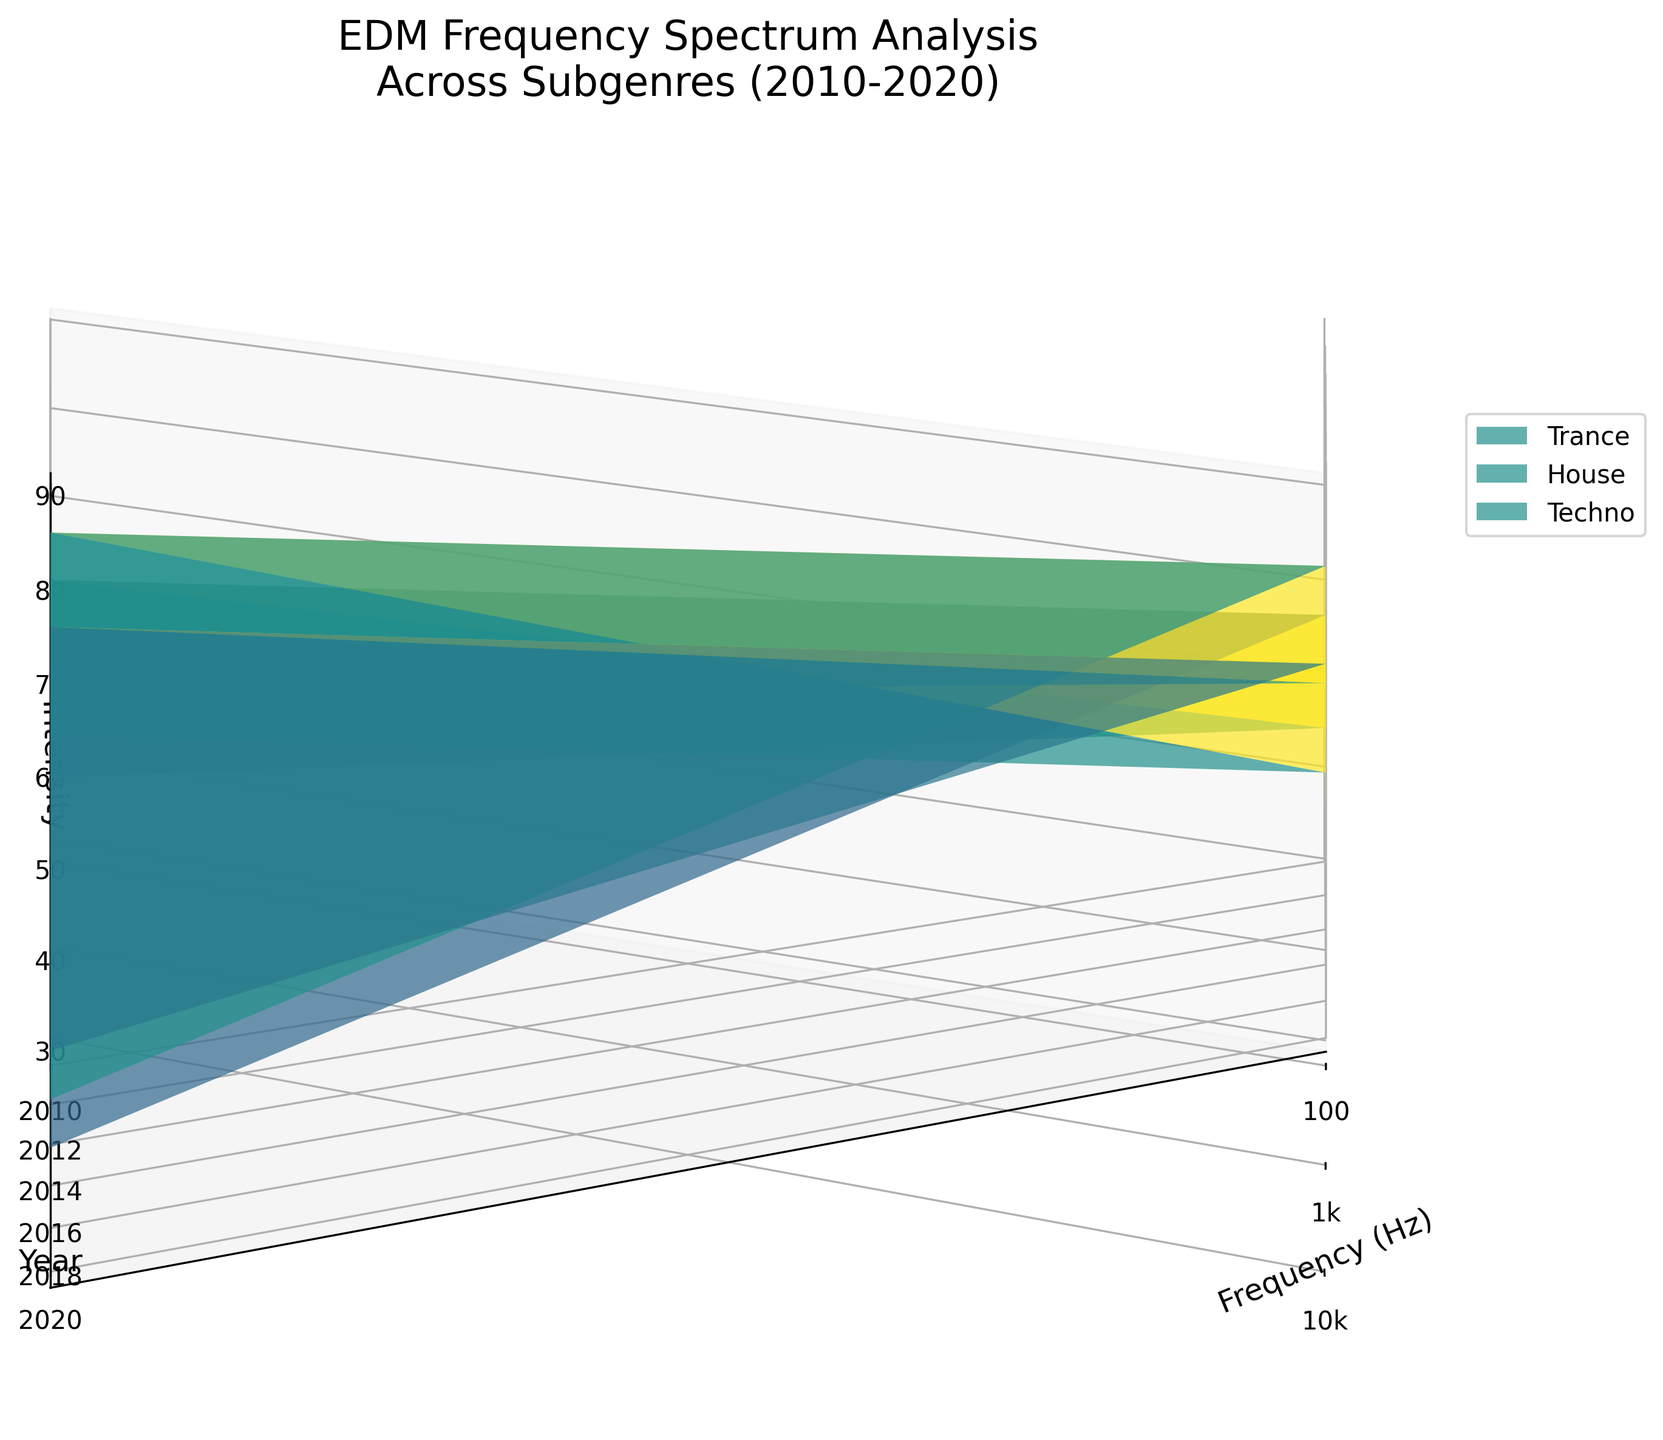What's the title of the figure? The title is prominently displayed at the top of the figure. It reads "EDM Frequency Spectrum Analysis Across Subgenres (2010-2020)."
Answer: EDM Frequency Spectrum Analysis Across Subgenres (2010-2020) What are the axes labeled as? The labels for the axes are as follows: the x-axis is labeled "Frequency (Hz)," the y-axis is labeled "Year," and the z-axis is labeled "Intensity."
Answer: Frequency (Hz), Year, Intensity Which subgenre has the highest intensity in 2020 at 1000 Hz? Look at the segment of the surface plot corresponding to the year 2020 and frequency 1000 Hz. Identify the subgenre with the highest z-value (Intensity). House has the highest intensity at this point.
Answer: House How does the intensity of Trance music at 10,000 Hz change from 2010 to 2020? Observe the z-values (Intensity) for Trance at the frequency 10,000 Hz from year 2010 to 2020. The intensity increases from 35 in 2010 to 45 in 2020.
Answer: Increases from 35 to 45 Compare the intensity of Techno and House at 100 Hz in 2015. Which is higher? Observe the z-values (Intensity) on the surface plot for Techno and House at the frequency 100 Hz in the year 2015. Techno has a higher intensity (60) compared to House (55).
Answer: Techno What trend can be observed in the intensity of all subgenres at 100 Hz from 2010 to 2020? Observe the trends in z-values (Intensity) at the frequency 100 Hz for all subgenres from the year 2010 to 2020. The intensity of all subgenres generally increases over time.
Answer: Intensity increases What is the range of intensity values for Techno at 1000 Hz across all years? Look at the z-values (Intensity) for Techno at the frequency 1000 Hz across all years. The intensity values range from 70 in 2010 to 80 in 2020.
Answer: 70 to 80 Which subgenre shows the least variation in intensity at 10,000 Hz from 2010 to 2020? Examine the z-values (Intensity) for each subgenre at the frequency 10,000 Hz from 2010 to 2020. Techno shows the least variation, with values ranging from 40 to 50.
Answer: Techno 